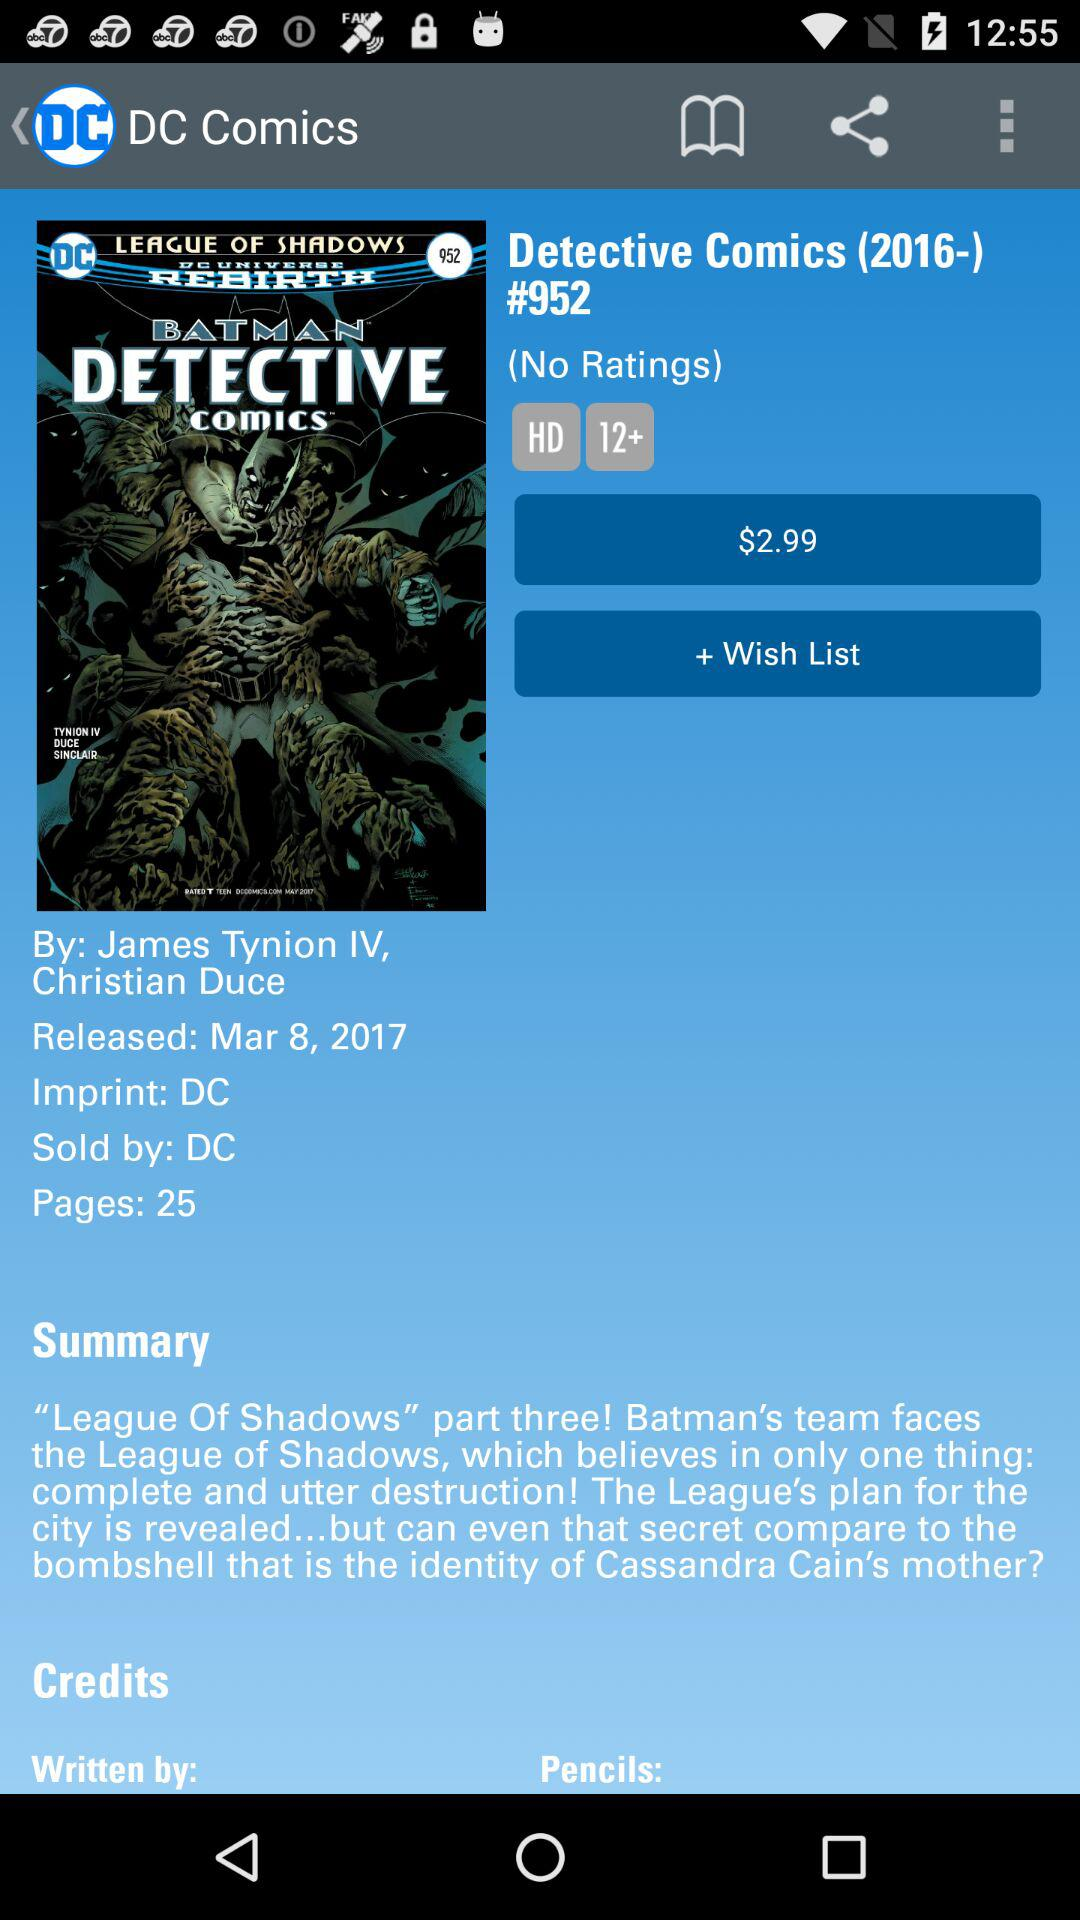What are the authors' names? The authors' names are James Tynion IV and Christian Duce. 